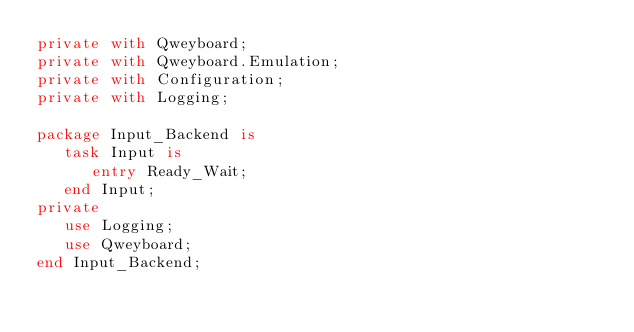Convert code to text. <code><loc_0><loc_0><loc_500><loc_500><_Ada_>private with Qweyboard;
private with Qweyboard.Emulation;
private with Configuration;
private with Logging;

package Input_Backend is
   task Input is
      entry Ready_Wait;
   end Input;
private
   use Logging;
   use Qweyboard;
end Input_Backend;
</code> 